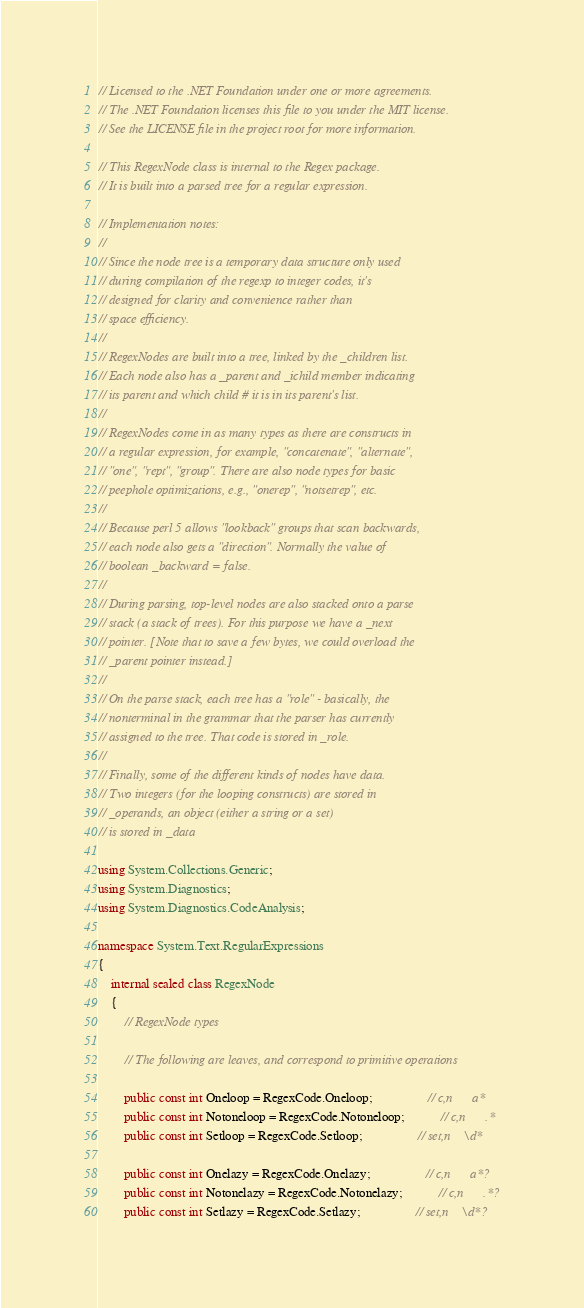Convert code to text. <code><loc_0><loc_0><loc_500><loc_500><_C#_>// Licensed to the .NET Foundation under one or more agreements.
// The .NET Foundation licenses this file to you under the MIT license.
// See the LICENSE file in the project root for more information.

// This RegexNode class is internal to the Regex package.
// It is built into a parsed tree for a regular expression.

// Implementation notes:
//
// Since the node tree is a temporary data structure only used
// during compilation of the regexp to integer codes, it's
// designed for clarity and convenience rather than
// space efficiency.
//
// RegexNodes are built into a tree, linked by the _children list.
// Each node also has a _parent and _ichild member indicating
// its parent and which child # it is in its parent's list.
//
// RegexNodes come in as many types as there are constructs in
// a regular expression, for example, "concatenate", "alternate",
// "one", "rept", "group". There are also node types for basic
// peephole optimizations, e.g., "onerep", "notsetrep", etc.
//
// Because perl 5 allows "lookback" groups that scan backwards,
// each node also gets a "direction". Normally the value of
// boolean _backward = false.
//
// During parsing, top-level nodes are also stacked onto a parse
// stack (a stack of trees). For this purpose we have a _next
// pointer. [Note that to save a few bytes, we could overload the
// _parent pointer instead.]
//
// On the parse stack, each tree has a "role" - basically, the
// nonterminal in the grammar that the parser has currently
// assigned to the tree. That code is stored in _role.
//
// Finally, some of the different kinds of nodes have data.
// Two integers (for the looping constructs) are stored in
// _operands, an object (either a string or a set)
// is stored in _data

using System.Collections.Generic;
using System.Diagnostics;
using System.Diagnostics.CodeAnalysis;

namespace System.Text.RegularExpressions
{
    internal sealed class RegexNode
    {
        // RegexNode types

        // The following are leaves, and correspond to primitive operations

        public const int Oneloop = RegexCode.Oneloop;                 // c,n      a*
        public const int Notoneloop = RegexCode.Notoneloop;           // c,n      .*
        public const int Setloop = RegexCode.Setloop;                 // set,n    \d*

        public const int Onelazy = RegexCode.Onelazy;                 // c,n      a*?
        public const int Notonelazy = RegexCode.Notonelazy;           // c,n      .*?
        public const int Setlazy = RegexCode.Setlazy;                 // set,n    \d*?
</code> 